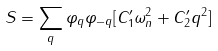Convert formula to latex. <formula><loc_0><loc_0><loc_500><loc_500>S = \sum _ { q } \varphi _ { q } \varphi _ { - q } [ C _ { 1 } ^ { \prime } \omega _ { n } ^ { 2 } + C _ { 2 } ^ { \prime } q ^ { 2 } ]</formula> 